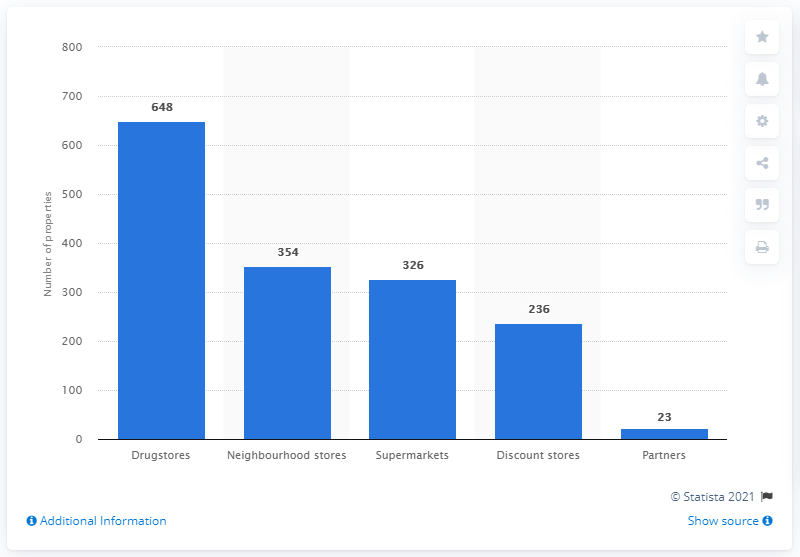Identify some key points in this picture. In 2020, Metro, Inc. operated a total of 236 discount stores in Ontario and Québec. It is Partners that has the least number of metro stations. In 2020, Metro, Inc. operated a total of 648 drugstores in Ontario and Québec. The average of the three middle factors is 305. 